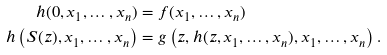<formula> <loc_0><loc_0><loc_500><loc_500>h ( 0 , x _ { 1 } , \dots , x _ { n } ) & = f ( x _ { 1 } , \dots , x _ { n } ) \\ h \left ( S ( z ) , x _ { 1 } , \dots , x _ { n } \right ) & = g \left ( z , h ( z , x _ { 1 } , \dots , x _ { n } ) , x _ { 1 } , \dots , x _ { n } \right ) .</formula> 